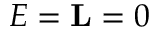<formula> <loc_0><loc_0><loc_500><loc_500>E = { L } = 0</formula> 